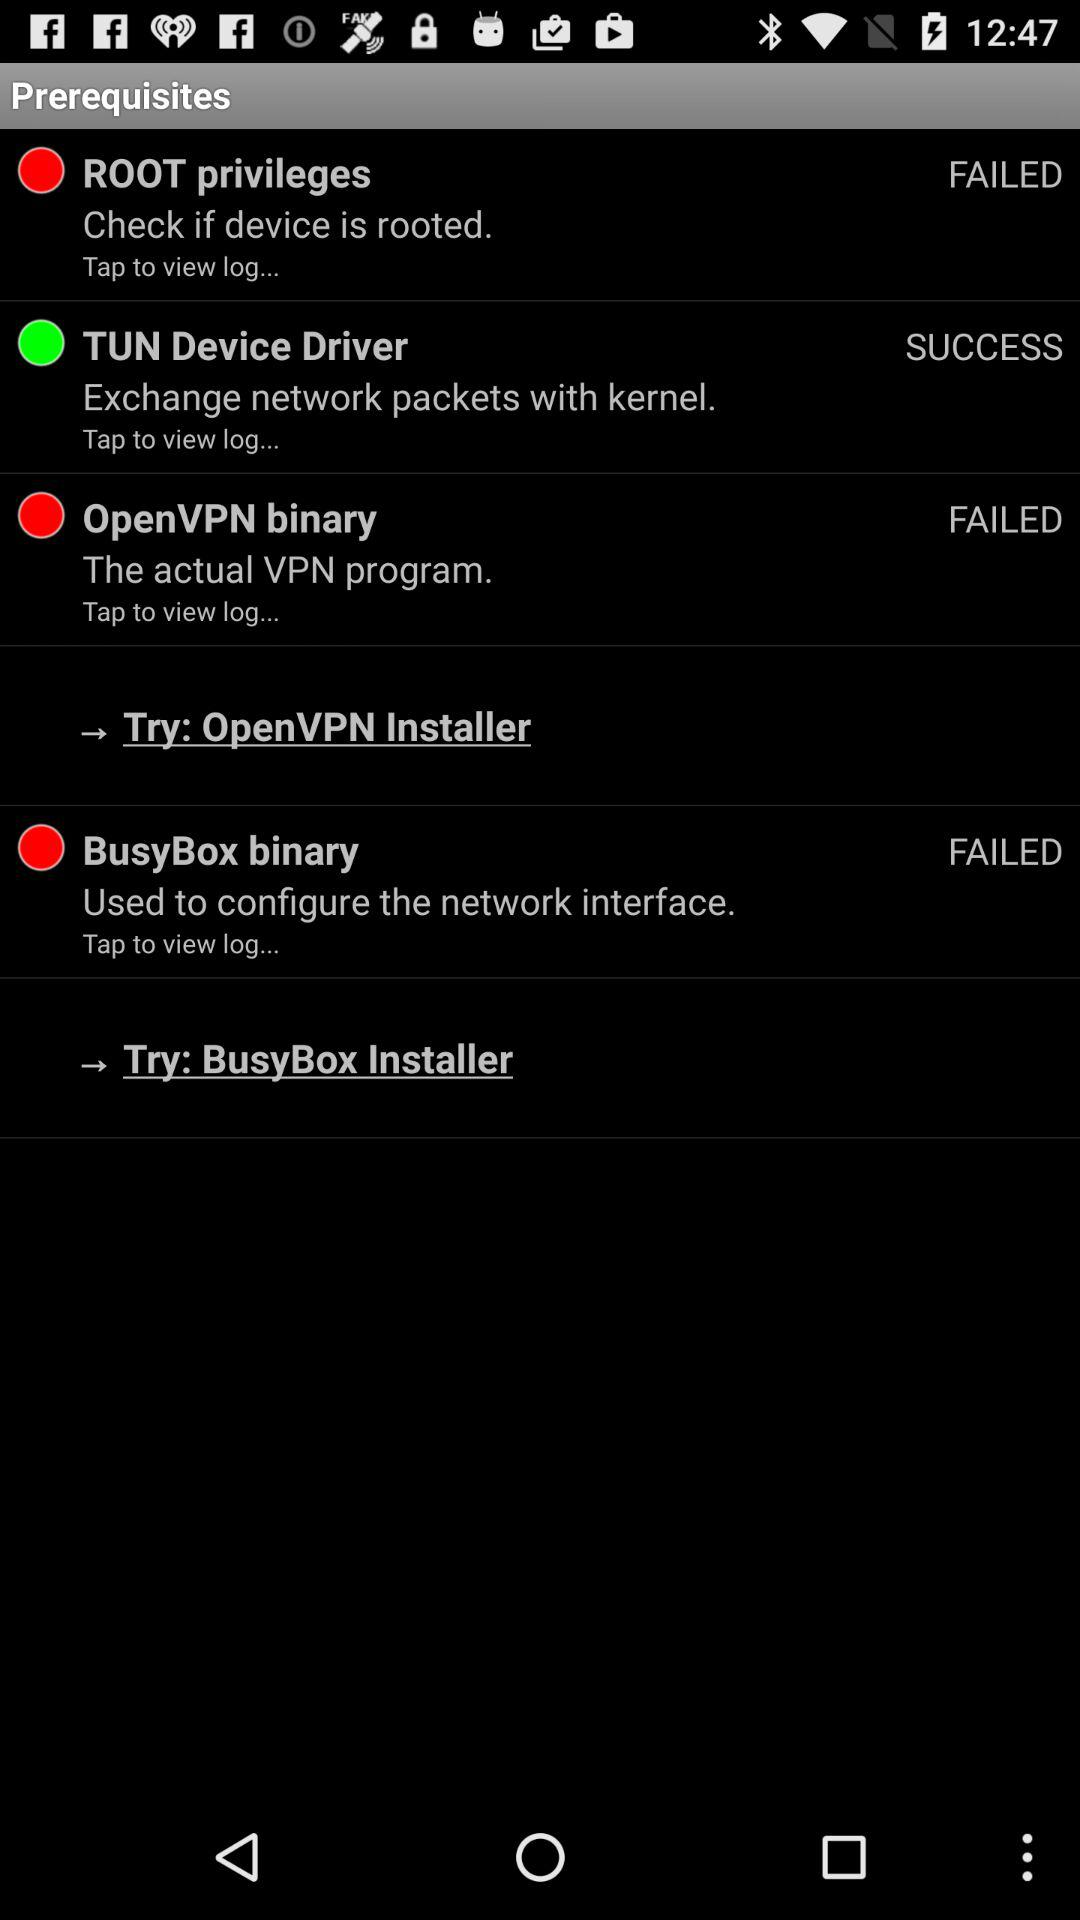The status of "Tun Device Driver" is failed or successful? The status is "SUCCESS". 